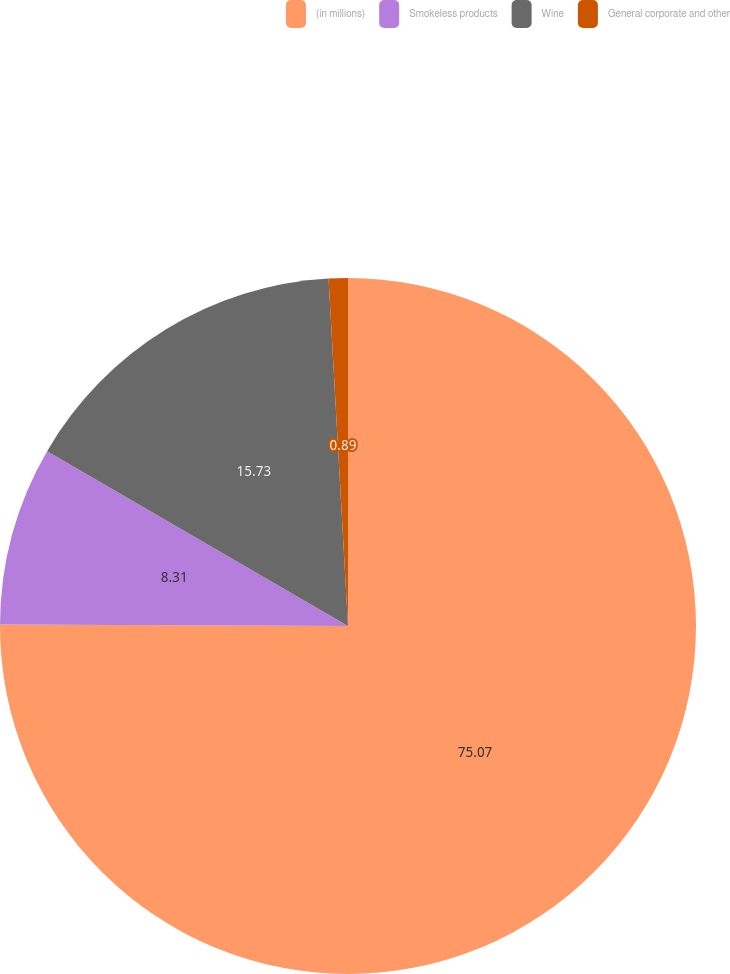<chart> <loc_0><loc_0><loc_500><loc_500><pie_chart><fcel>(in millions)<fcel>Smokeless products<fcel>Wine<fcel>General corporate and other<nl><fcel>75.06%<fcel>8.31%<fcel>15.73%<fcel>0.89%<nl></chart> 